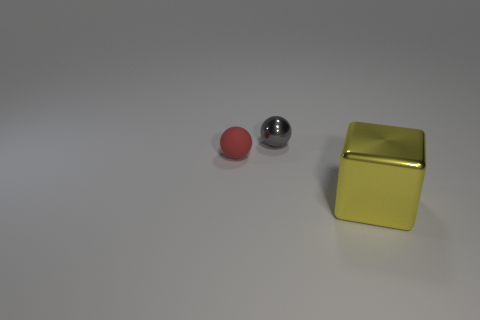Do the small gray thing and the small red rubber thing have the same shape?
Give a very brief answer. Yes. What is the color of the thing that is right of the red thing and in front of the shiny ball?
Make the answer very short. Yellow. What number of tiny things are either matte balls or green things?
Provide a succinct answer. 1. What material is the object that is right of the metallic object behind the ball that is in front of the gray metallic ball?
Offer a terse response. Metal. What number of shiny things are either red spheres or big green cubes?
Ensure brevity in your answer.  0. How many yellow objects are tiny balls or large rubber cubes?
Make the answer very short. 0. Is the small gray object made of the same material as the red object?
Ensure brevity in your answer.  No. Is the number of blocks that are on the right side of the big yellow metallic cube the same as the number of blocks in front of the matte sphere?
Give a very brief answer. No. What material is the other object that is the same shape as the gray object?
Provide a short and direct response. Rubber. What shape is the metal object that is in front of the red rubber thing that is to the left of the ball that is to the right of the tiny red matte sphere?
Your answer should be very brief. Cube. 